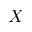Convert formula to latex. <formula><loc_0><loc_0><loc_500><loc_500>X</formula> 